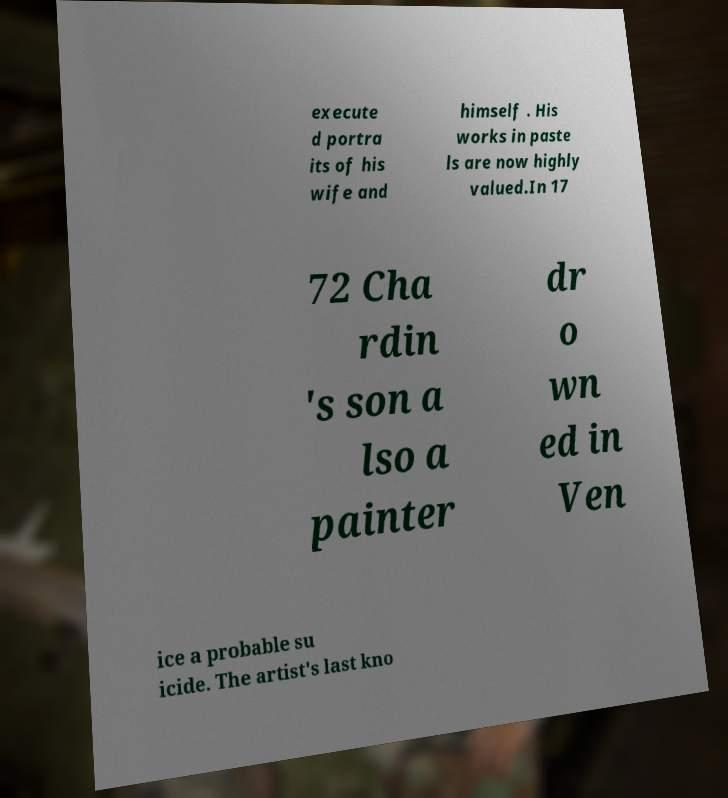Could you assist in decoding the text presented in this image and type it out clearly? execute d portra its of his wife and himself . His works in paste ls are now highly valued.In 17 72 Cha rdin 's son a lso a painter dr o wn ed in Ven ice a probable su icide. The artist's last kno 